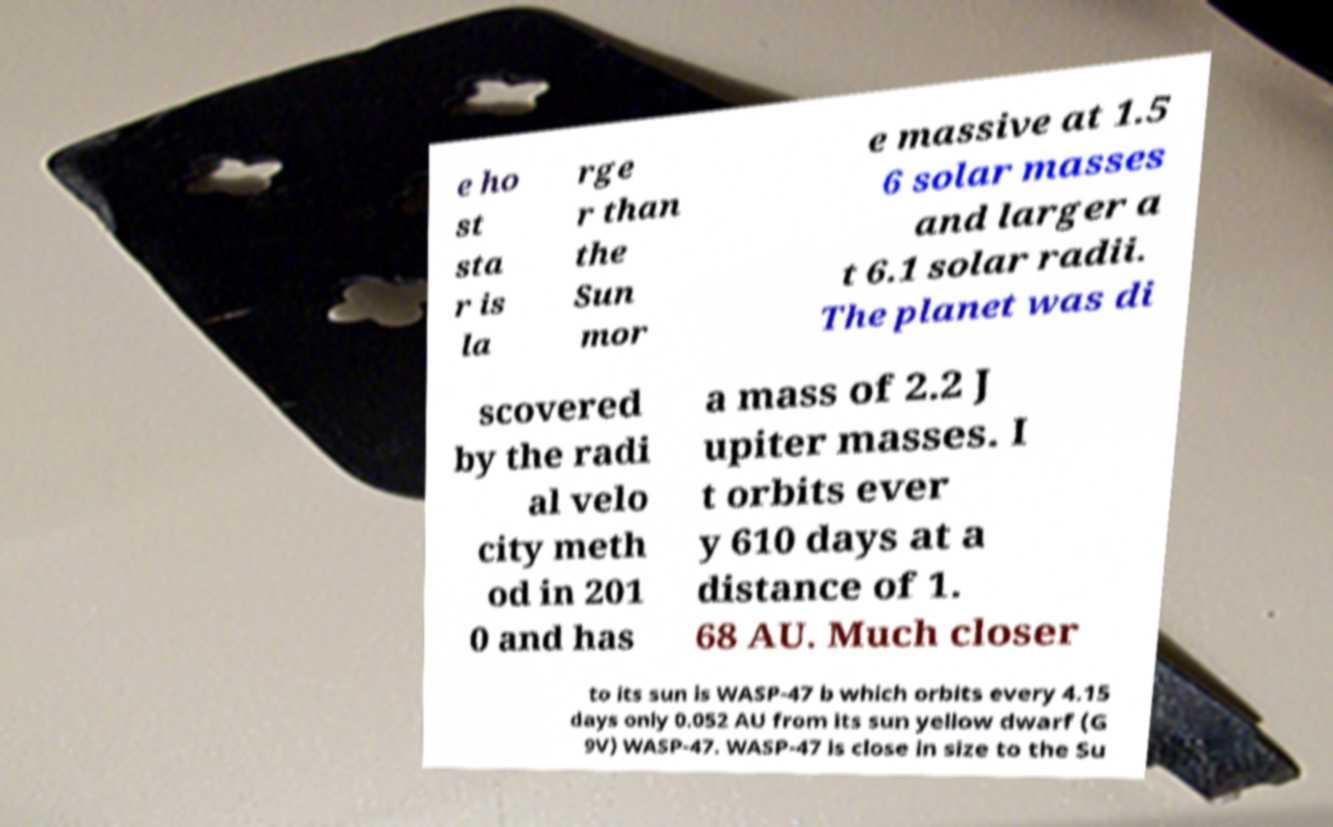What messages or text are displayed in this image? I need them in a readable, typed format. e ho st sta r is la rge r than the Sun mor e massive at 1.5 6 solar masses and larger a t 6.1 solar radii. The planet was di scovered by the radi al velo city meth od in 201 0 and has a mass of 2.2 J upiter masses. I t orbits ever y 610 days at a distance of 1. 68 AU. Much closer to its sun is WASP-47 b which orbits every 4.15 days only 0.052 AU from its sun yellow dwarf (G 9V) WASP-47. WASP-47 is close in size to the Su 